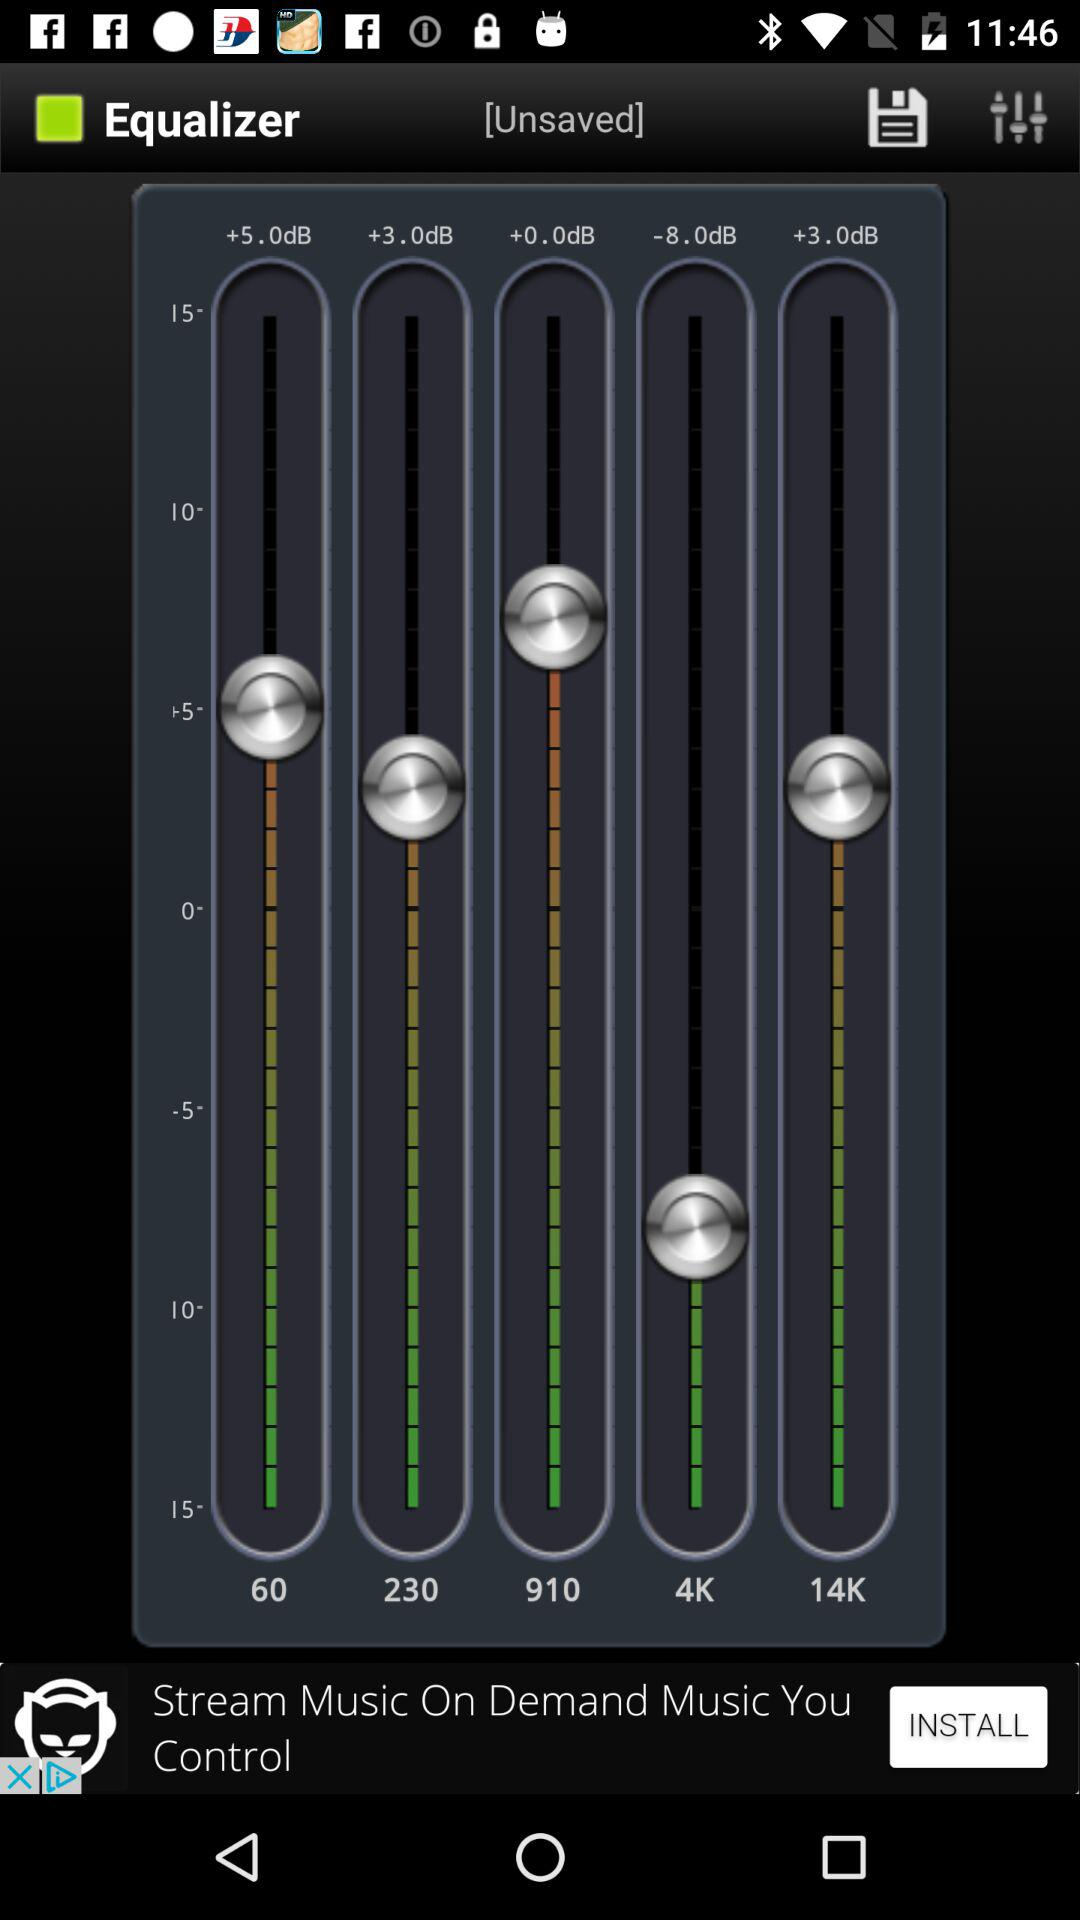What is the name of the application? The name of the application is "Equalizer". 